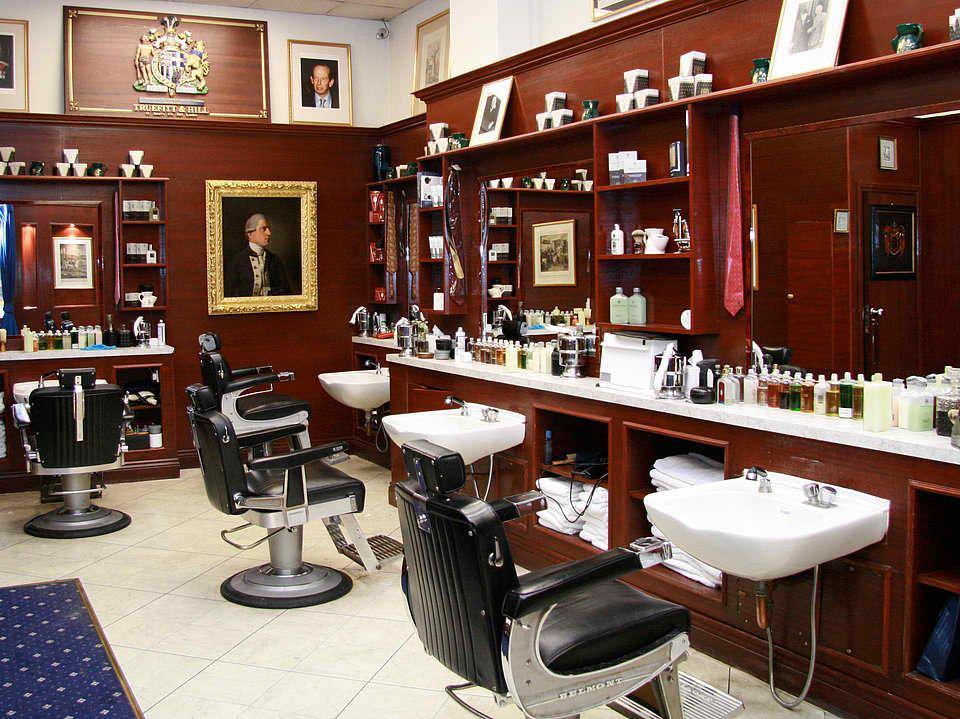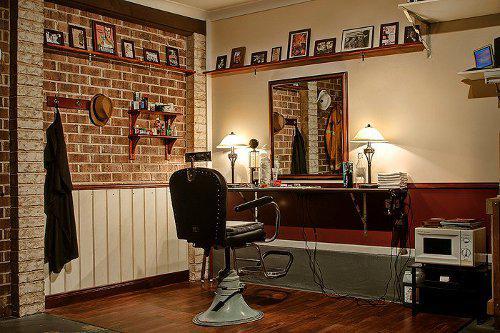The first image is the image on the left, the second image is the image on the right. Evaluate the accuracy of this statement regarding the images: "the left image contains at least three chairs, the right image only contains one.". Is it true? Answer yes or no. Yes. The first image is the image on the left, the second image is the image on the right. Evaluate the accuracy of this statement regarding the images: "in at least one image there is a single empty barber chair facing a mirror next to a framed picture.". Is it true? Answer yes or no. Yes. 